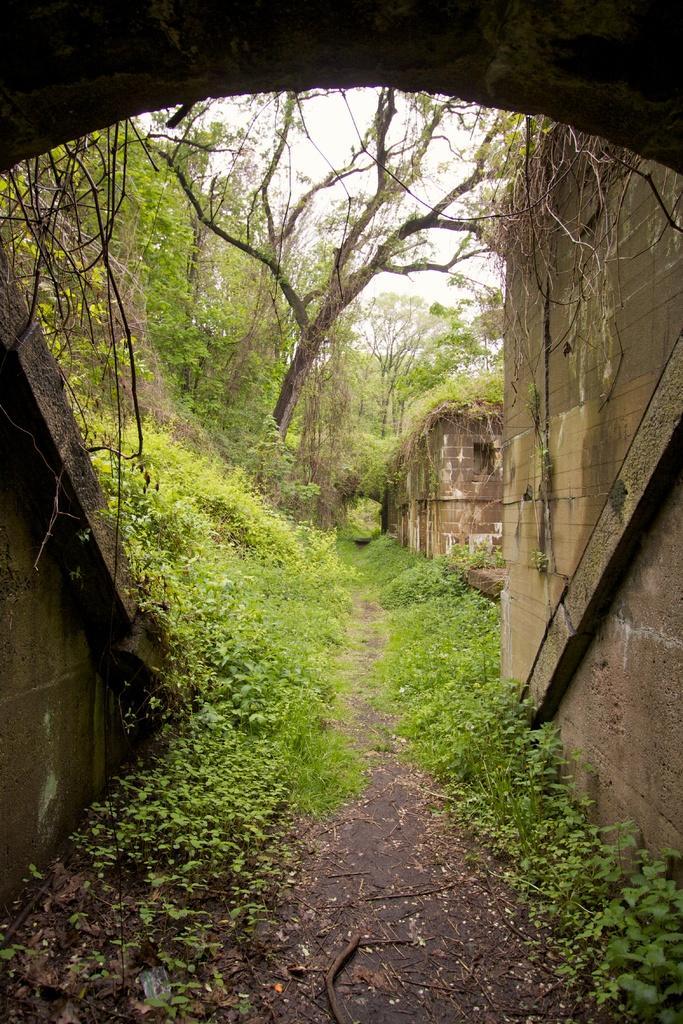Could you give a brief overview of what you see in this image? At the bottom of the picture, we see the road and herbs. There are many trees in the background and we even see a building. 